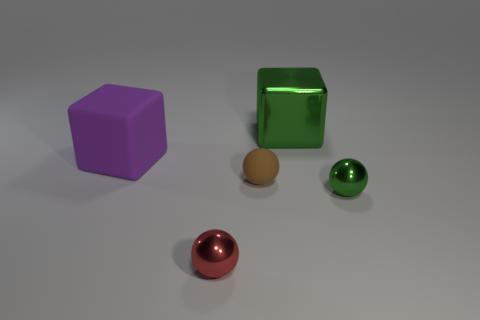How many objects are either big green things or small spheres that are to the right of the tiny red sphere?
Offer a terse response. 3. How many other things are the same size as the green metal block?
Offer a terse response. 1. Is the green object that is in front of the matte cube made of the same material as the sphere that is behind the small green metallic object?
Give a very brief answer. No. How many red metal things are behind the red thing?
Offer a very short reply. 0. How many yellow objects are tiny objects or matte balls?
Provide a short and direct response. 0. There is a green block that is the same size as the purple matte thing; what material is it?
Make the answer very short. Metal. What is the shape of the thing that is both behind the brown rubber thing and right of the big purple rubber thing?
Ensure brevity in your answer.  Cube. What is the color of the other rubber sphere that is the same size as the red ball?
Provide a short and direct response. Brown. Does the rubber object that is behind the brown sphere have the same size as the matte object that is on the right side of the purple rubber object?
Your answer should be compact. No. How big is the green thing behind the big cube that is in front of the thing that is behind the purple cube?
Keep it short and to the point. Large. 